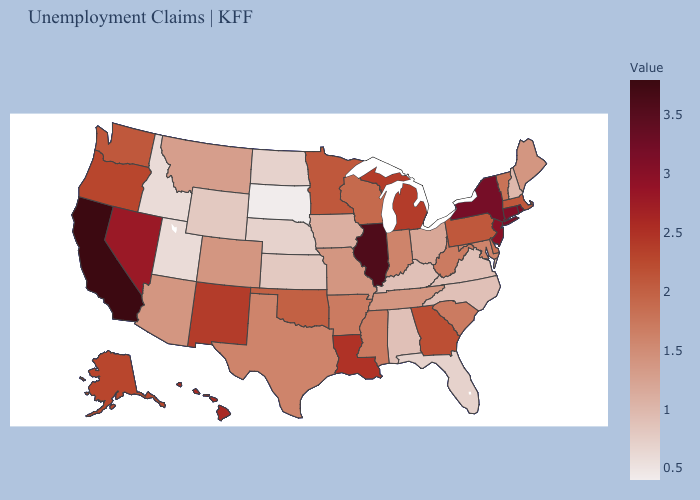Among the states that border Nebraska , does Wyoming have the highest value?
Keep it brief. No. Among the states that border Georgia , does Florida have the lowest value?
Give a very brief answer. Yes. Does Delaware have a higher value than New Hampshire?
Keep it brief. Yes. Among the states that border Washington , which have the lowest value?
Quick response, please. Idaho. Which states have the highest value in the USA?
Concise answer only. California. 